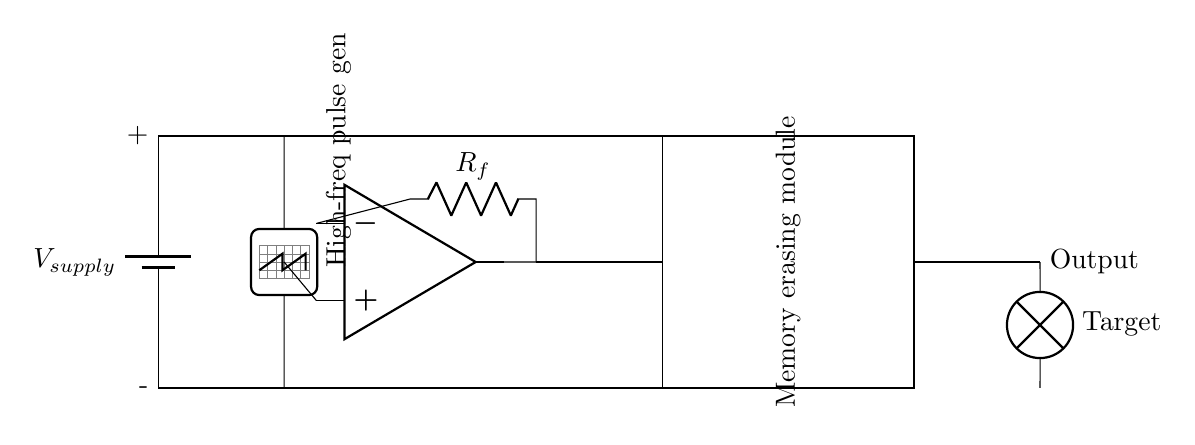What component generates high-frequency pulses? The component labeled as "High-freq pulse gen" in the circuit diagram indicates that it is responsible for generating high-frequency pulses.
Answer: High-freq pulse gen What is the role of the op-amp in this circuit? The operational amplifier, or op-amp, is used for amplification in this circuit, as indicated by its connection to the feedback resistor and the output path.
Answer: Amplification How many resistors are present in the circuit? The circuit diagram shows one resistor labeled as R_f, hence there is only one resistor present.
Answer: One What is the output target in this memory-erasing device? The output target is identified as "Target" which represents the load being affected by the circuit's function, specifically the memory erasing process.
Answer: Target What is the function of the memory erasing module? The memory erasing module is indicated in the diagram as the component responsible for executing the memory erasure process, suggested by its labeling.
Answer: Memory erasing How does current flow from the supply to the output? Current flows from the voltage supply, through the high-frequency pulse generator and op-amp, and finally to the memory erasing module before reaching the output, as shown by the connections in the circuit.
Answer: Supply to output What connects the op-amp to the memory erasing module? A direct wire connection is drawn from the output of the op-amp to the memory erasing module, indicating that the output signal from the op-amp drives the operation of the memory erasing module.
Answer: Direct wire connection 